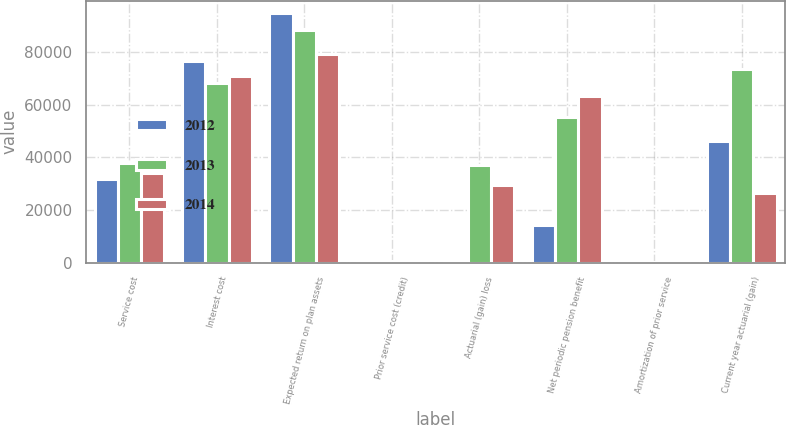<chart> <loc_0><loc_0><loc_500><loc_500><stacked_bar_chart><ecel><fcel>Service cost<fcel>Interest cost<fcel>Expected return on plan assets<fcel>Prior service cost (credit)<fcel>Actuarial (gain) loss<fcel>Net periodic pension benefit<fcel>Amortization of prior service<fcel>Current year actuarial (gain)<nl><fcel>2012<fcel>31773<fcel>76652<fcel>94838<fcel>724<fcel>131<fcel>14180<fcel>166<fcel>46119<nl><fcel>2013<fcel>37872<fcel>68096<fcel>88429<fcel>724<fcel>37170<fcel>55433<fcel>174<fcel>73472<nl><fcel>2014<fcel>34209<fcel>70866<fcel>79272<fcel>723<fcel>29636<fcel>63297<fcel>176<fcel>26425<nl></chart> 